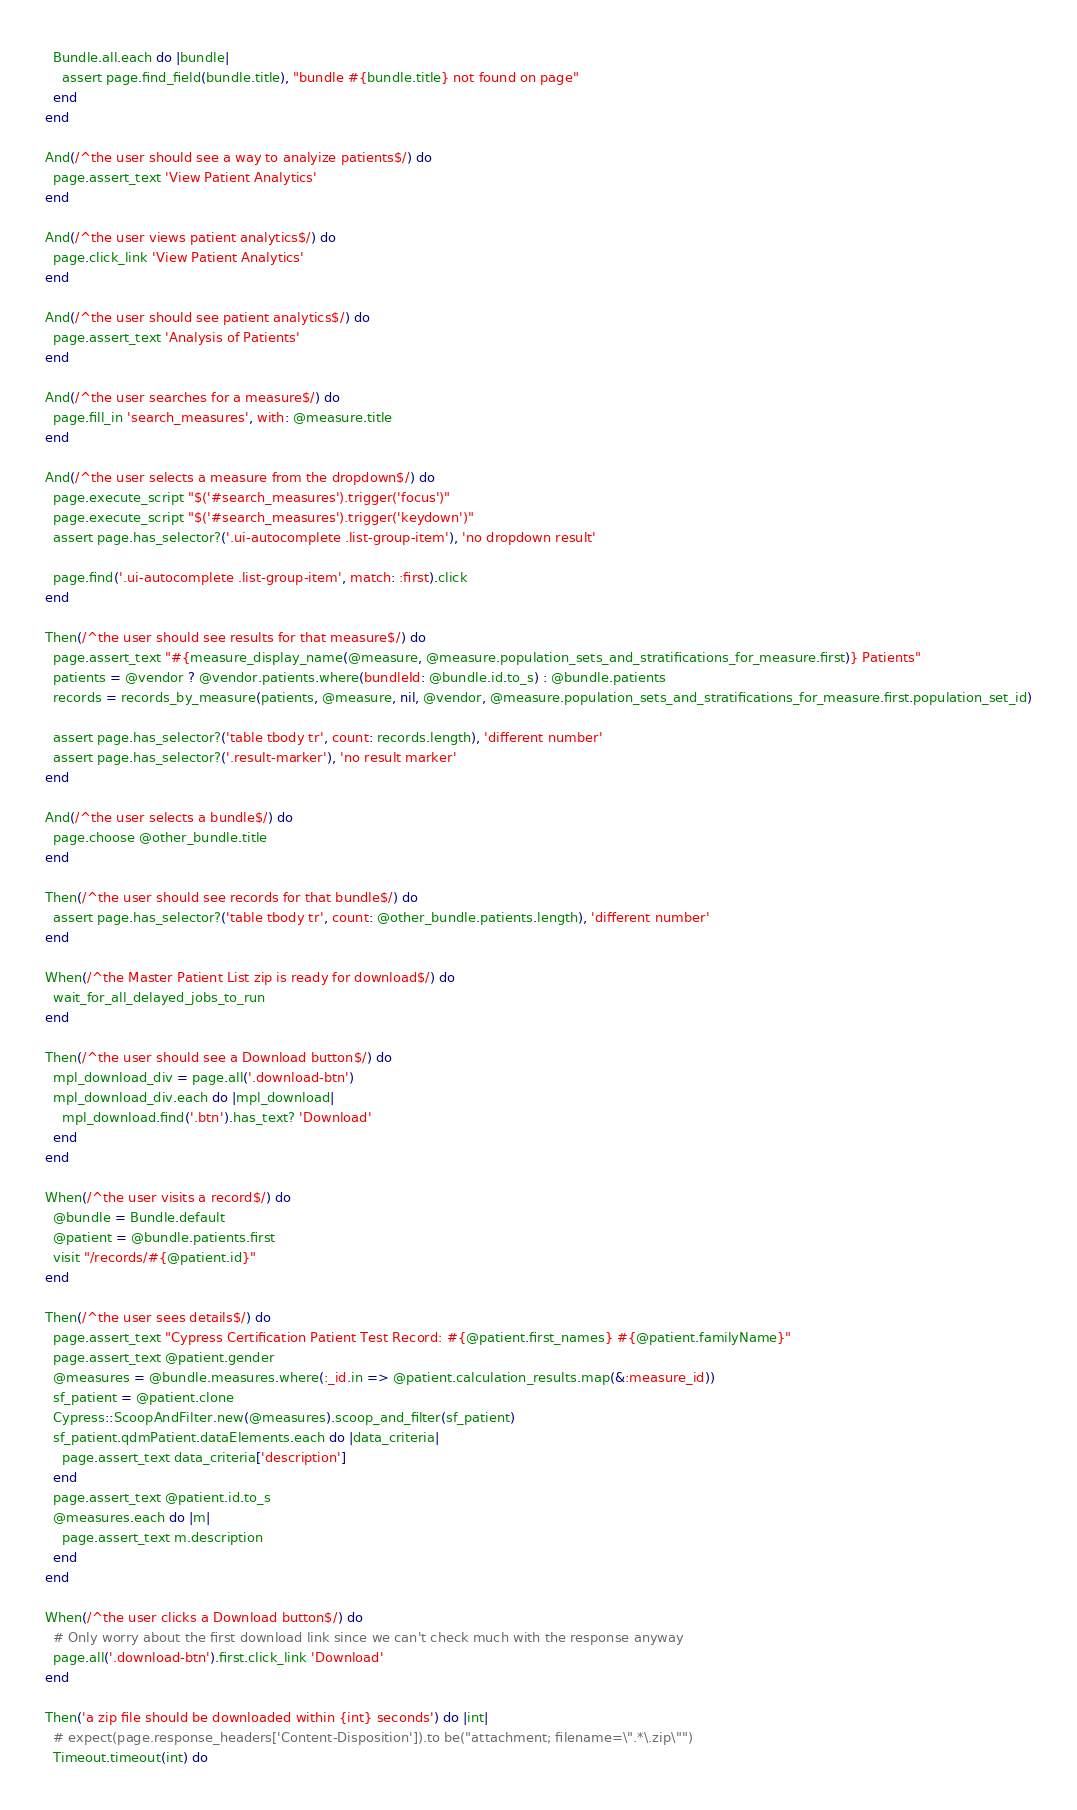<code> <loc_0><loc_0><loc_500><loc_500><_Ruby_>  Bundle.all.each do |bundle|
    assert page.find_field(bundle.title), "bundle #{bundle.title} not found on page"
  end
end

And(/^the user should see a way to analyize patients$/) do
  page.assert_text 'View Patient Analytics'
end

And(/^the user views patient analytics$/) do
  page.click_link 'View Patient Analytics'
end

And(/^the user should see patient analytics$/) do
  page.assert_text 'Analysis of Patients'
end

And(/^the user searches for a measure$/) do
  page.fill_in 'search_measures', with: @measure.title
end

And(/^the user selects a measure from the dropdown$/) do
  page.execute_script "$('#search_measures').trigger('focus')"
  page.execute_script "$('#search_measures').trigger('keydown')"
  assert page.has_selector?('.ui-autocomplete .list-group-item'), 'no dropdown result'

  page.find('.ui-autocomplete .list-group-item', match: :first).click
end

Then(/^the user should see results for that measure$/) do
  page.assert_text "#{measure_display_name(@measure, @measure.population_sets_and_stratifications_for_measure.first)} Patients"
  patients = @vendor ? @vendor.patients.where(bundleId: @bundle.id.to_s) : @bundle.patients
  records = records_by_measure(patients, @measure, nil, @vendor, @measure.population_sets_and_stratifications_for_measure.first.population_set_id)

  assert page.has_selector?('table tbody tr', count: records.length), 'different number'
  assert page.has_selector?('.result-marker'), 'no result marker'
end

And(/^the user selects a bundle$/) do
  page.choose @other_bundle.title
end

Then(/^the user should see records for that bundle$/) do
  assert page.has_selector?('table tbody tr', count: @other_bundle.patients.length), 'different number'
end

When(/^the Master Patient List zip is ready for download$/) do
  wait_for_all_delayed_jobs_to_run
end

Then(/^the user should see a Download button$/) do
  mpl_download_div = page.all('.download-btn')
  mpl_download_div.each do |mpl_download|
    mpl_download.find('.btn').has_text? 'Download'
  end
end

When(/^the user visits a record$/) do
  @bundle = Bundle.default
  @patient = @bundle.patients.first
  visit "/records/#{@patient.id}"
end

Then(/^the user sees details$/) do
  page.assert_text "Cypress Certification Patient Test Record: #{@patient.first_names} #{@patient.familyName}"
  page.assert_text @patient.gender
  @measures = @bundle.measures.where(:_id.in => @patient.calculation_results.map(&:measure_id))
  sf_patient = @patient.clone
  Cypress::ScoopAndFilter.new(@measures).scoop_and_filter(sf_patient)
  sf_patient.qdmPatient.dataElements.each do |data_criteria|
    page.assert_text data_criteria['description']
  end
  page.assert_text @patient.id.to_s
  @measures.each do |m|
    page.assert_text m.description
  end
end

When(/^the user clicks a Download button$/) do
  # Only worry about the first download link since we can't check much with the response anyway
  page.all('.download-btn').first.click_link 'Download'
end

Then('a zip file should be downloaded within {int} seconds') do |int|
  # expect(page.response_headers['Content-Disposition']).to be("attachment; filename=\".*\.zip\"")
  Timeout.timeout(int) do</code> 